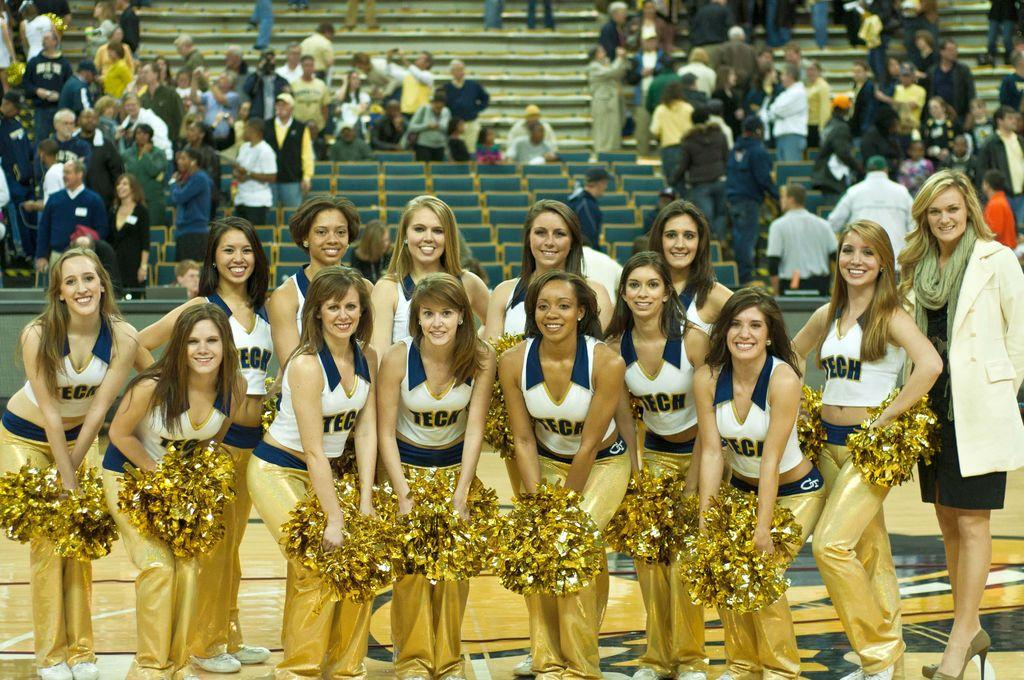<image>
Share a concise interpretation of the image provided. a group of cheerleaders with the word tech on their jerseys 